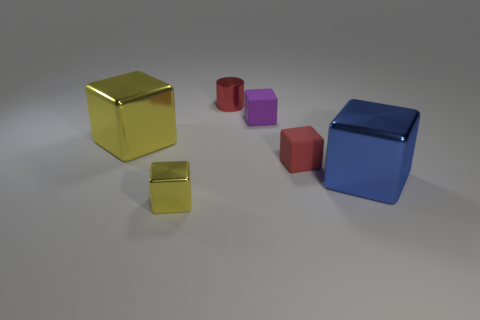The thing in front of the big object that is to the right of the yellow metal block behind the blue object is what color?
Ensure brevity in your answer.  Yellow. How many other objects are there of the same color as the small cylinder?
Provide a short and direct response. 1. What number of shiny objects are either gray spheres or red cubes?
Provide a short and direct response. 0. There is a large shiny cube on the left side of the large blue cube; does it have the same color as the small metallic thing that is in front of the large yellow cube?
Your response must be concise. Yes. Is there any other thing that is the same material as the red cylinder?
Your answer should be very brief. Yes. What is the size of the blue thing that is the same shape as the tiny yellow shiny thing?
Offer a terse response. Large. Are there more large blocks that are to the right of the small yellow thing than small cylinders?
Offer a very short reply. No. Are the purple object in front of the metallic cylinder and the large yellow thing made of the same material?
Provide a succinct answer. No. There is a yellow block that is behind the yellow metal object that is in front of the small rubber block that is in front of the purple thing; how big is it?
Provide a succinct answer. Large. The blue block that is the same material as the red cylinder is what size?
Ensure brevity in your answer.  Large. 